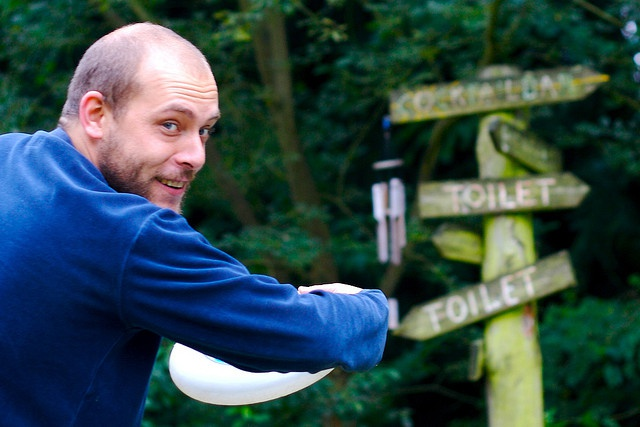Describe the objects in this image and their specific colors. I can see people in darkgreen, navy, black, blue, and pink tones and frisbee in darkgreen, lightgray, black, and gray tones in this image. 